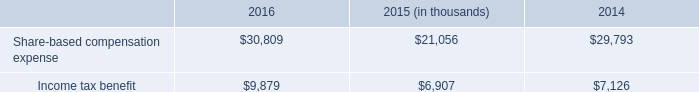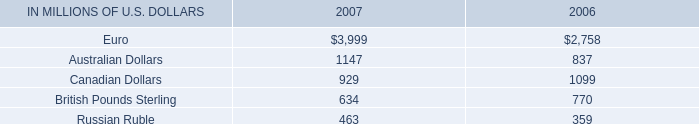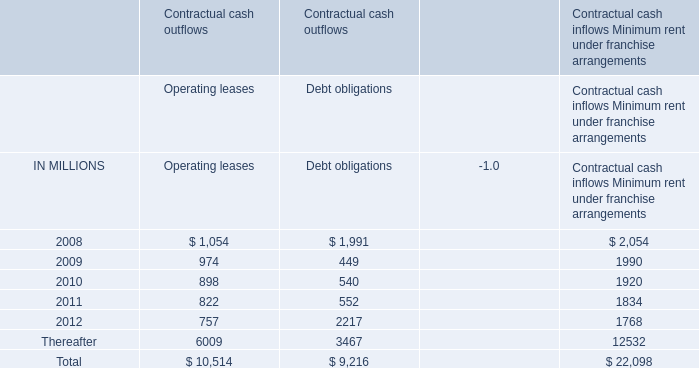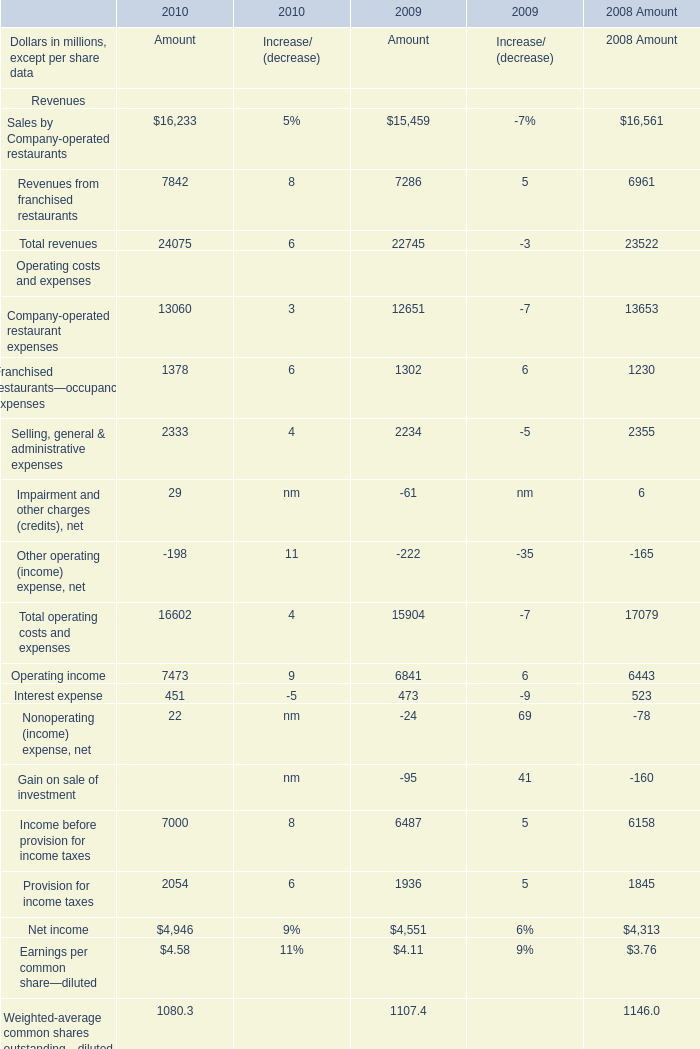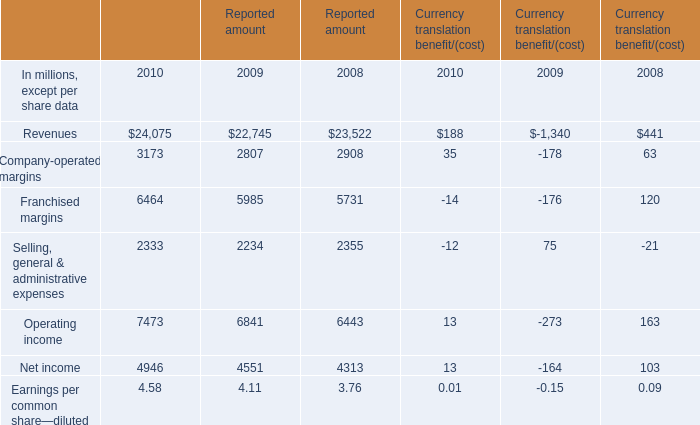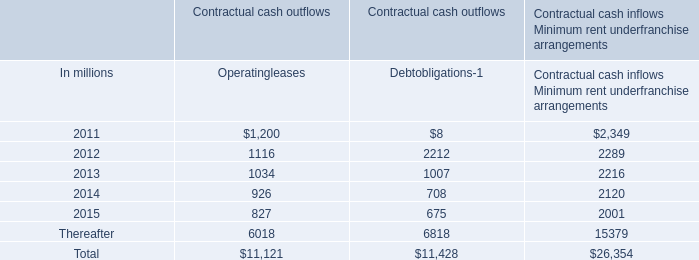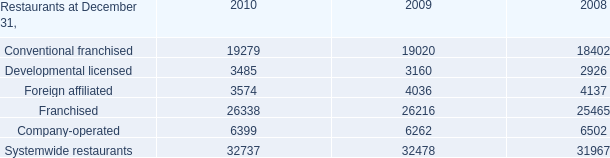What is the percentage of all Currency translation benefit/(cost) that are positive to the total amount, in 2010? 
Computations: (((((35 + 188) + 13) + 13) + 0.01) / ((((((35 + 188) + 13) + 13) + 0.01) - 14) - 12))
Answer: 1.11659. 